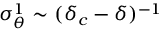<formula> <loc_0><loc_0><loc_500><loc_500>\sigma _ { \theta } ^ { 1 } \sim ( \delta _ { c } - \delta ) ^ { - 1 }</formula> 